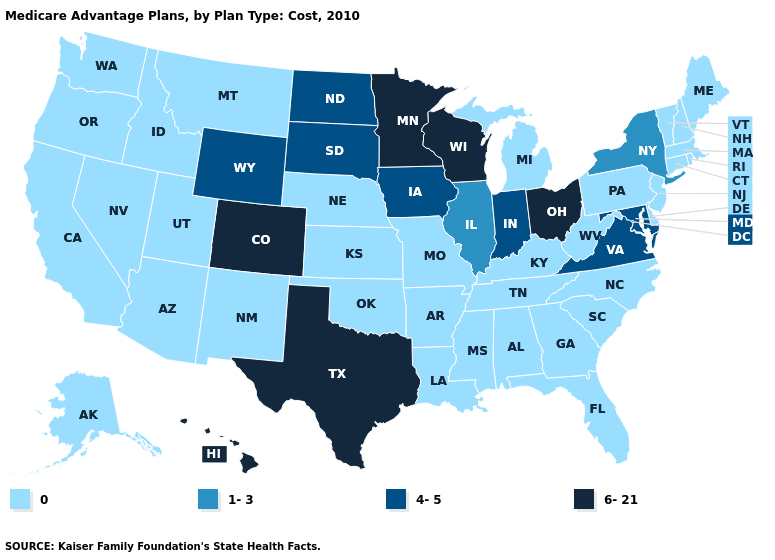Does Nebraska have the lowest value in the USA?
Be succinct. Yes. Which states have the highest value in the USA?
Short answer required. Colorado, Hawaii, Minnesota, Ohio, Texas, Wisconsin. Name the states that have a value in the range 0?
Write a very short answer. Alaska, Alabama, Arkansas, Arizona, California, Connecticut, Delaware, Florida, Georgia, Idaho, Kansas, Kentucky, Louisiana, Massachusetts, Maine, Michigan, Missouri, Mississippi, Montana, North Carolina, Nebraska, New Hampshire, New Jersey, New Mexico, Nevada, Oklahoma, Oregon, Pennsylvania, Rhode Island, South Carolina, Tennessee, Utah, Vermont, Washington, West Virginia. What is the value of Alaska?
Be succinct. 0. What is the lowest value in states that border Minnesota?
Quick response, please. 4-5. What is the highest value in the South ?
Answer briefly. 6-21. Among the states that border New Mexico , which have the lowest value?
Be succinct. Arizona, Oklahoma, Utah. What is the value of Iowa?
Quick response, please. 4-5. What is the value of Maryland?
Quick response, please. 4-5. Which states have the lowest value in the Northeast?
Keep it brief. Connecticut, Massachusetts, Maine, New Hampshire, New Jersey, Pennsylvania, Rhode Island, Vermont. Which states have the lowest value in the West?
Give a very brief answer. Alaska, Arizona, California, Idaho, Montana, New Mexico, Nevada, Oregon, Utah, Washington. Name the states that have a value in the range 1-3?
Quick response, please. Illinois, New York. What is the highest value in the West ?
Keep it brief. 6-21. What is the lowest value in the USA?
Give a very brief answer. 0. What is the highest value in the South ?
Write a very short answer. 6-21. 